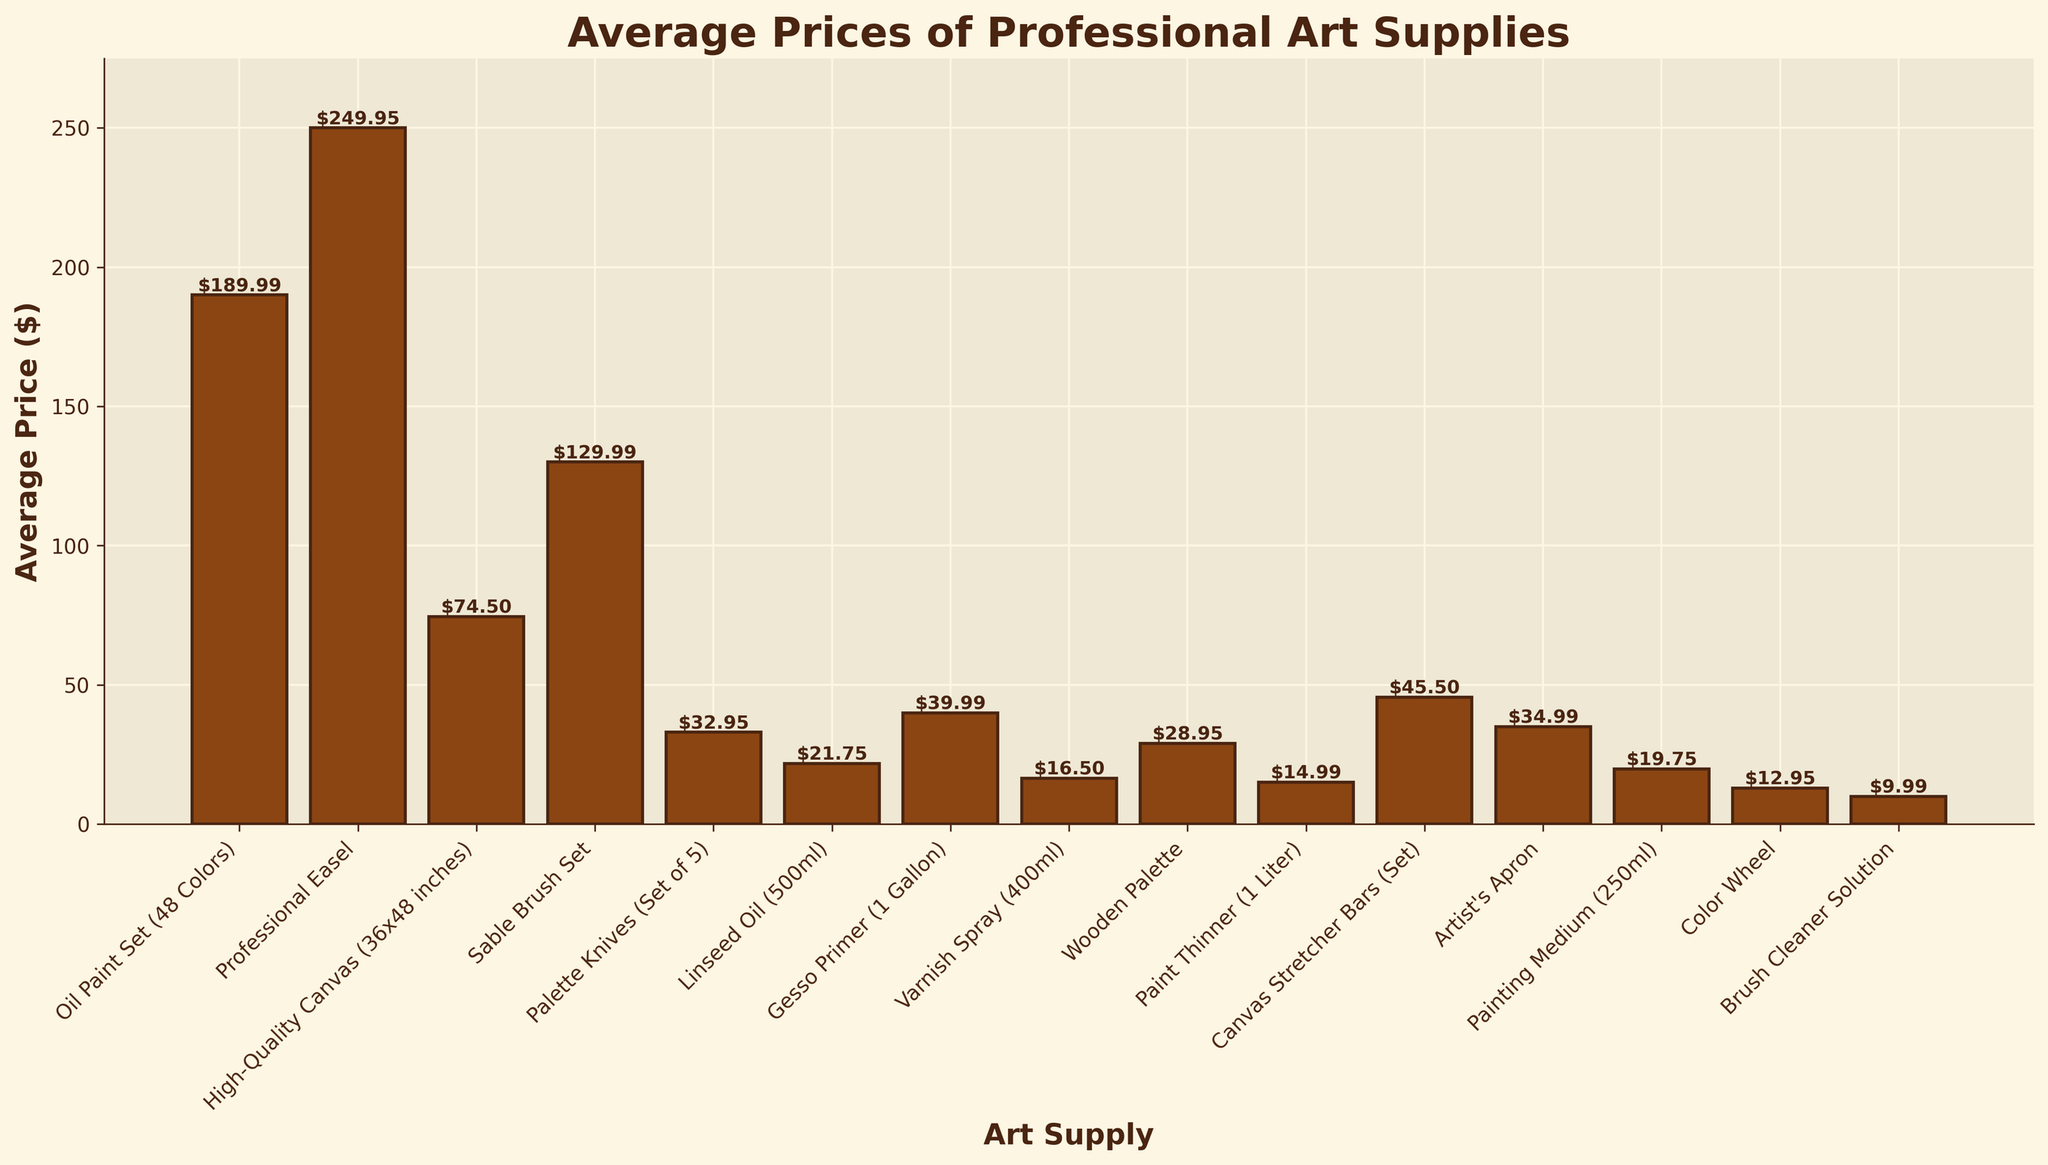Which art supply has the highest average price? The highest bar on the chart represents the "Professional Easel" category, indicating it has the highest average price.
Answer: Professional Easel What is the average price difference between the most expensive and least expensive art supplies? The most expensive art supply is the "Professional Easel" at $249.95, and the least expensive is the "Brush Cleaner Solution" at $9.99. The difference is calculated as $249.95 - $9.99.
Answer: $239.96 What is the total average price of the "Oil Paint Set (48 Colors)" and "High-Quality Canvas (36x48 inches)" combined? The "Oil Paint Set (48 Colors)" is priced at $189.99, and the "High-Quality Canvas (36x48 inches)" is priced at $74.50. The total price is $189.99 + $74.50.
Answer: $264.49 Which art supply is less expensive: "Linseed Oil (500ml)" or "Varnish Spray (400ml)"? By comparing the heights of the bars, the "Varnish Spray (400ml)" is higher priced at $16.50 compared to the "Linseed Oil (500ml)" at $21.75.
Answer: Varnish Spray (400ml) Arrange the following supplies in ascending order of their prices: "Sable Brush Set", "Palette Knives (Set of 5)", and "Wooden Palette". The prices are "Sable Brush Set" at $129.99, "Palette Knives (Set of 5)" at $32.95, and "Wooden Palette" at $28.95. In ascending order: Wooden Palette, Palette Knives, Sable Brush Set.
Answer: Wooden Palette, Palette Knives, Sable Brush Set Which expenditures add up to more than $100 when combined: "Paint Thinner (1 Liter)", "Artist's Apron", and "Gesso Primer (1 Gallon)"? The prices are "Paint Thinner (1 Liter)" at $14.99, "Artist's Apron" at $34.99, and "Gesso Primer (1 Gallon)" at $39.99. Combined, the total is $14.99 + $34.99 + $39.99 = $89.97, so they do not add up to more than $100.
Answer: None Relative to the "Wooden Palette", how much more expensive is the "Canvas Stretcher Bars (Set)"? The "Wooden Palette" is priced at $28.95, and the "Canvas Stretcher Bars (Set)" is at $45.50. The price difference is $45.50 - $28.95.
Answer: $16.55 What is the average price of the "Color Wheel" and "Brush Cleaner Solution"? The prices are "Color Wheel" at $12.95 and "Brush Cleaner Solution" at $9.99. The average price is calculated as ($12.95 + $9.99) / 2.
Answer: $11.47 What is the price difference between "Gesso Primer (1 Gallon)" and "Painting Medium (250ml)"? The "Gesso Primer (1 Gallon)" is priced at $39.99 and the "Painting Medium (250ml)" is at $19.75. The difference is $39.99 - $19.75.
Answer: $20.24 